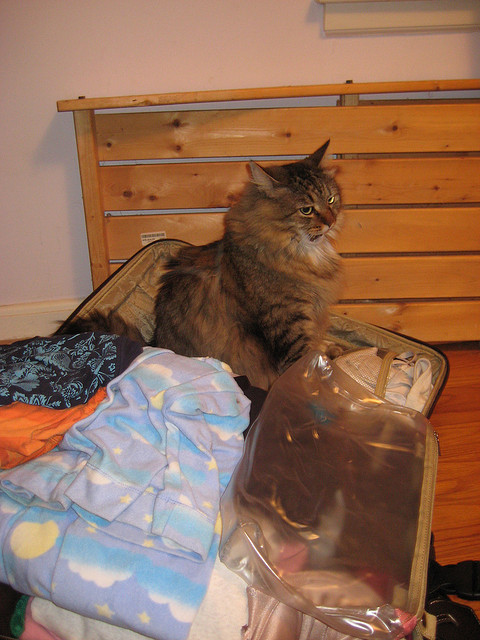<image>What type of pictures are on the purple blanket? I don't know what type of pictures are on the purple blanket. They can be clouds, stars, sun, or nothing. What type of pictures are on the purple blanket? I don't know what type of pictures are on the purple blanket. It is possible that there are no pictures on it. 